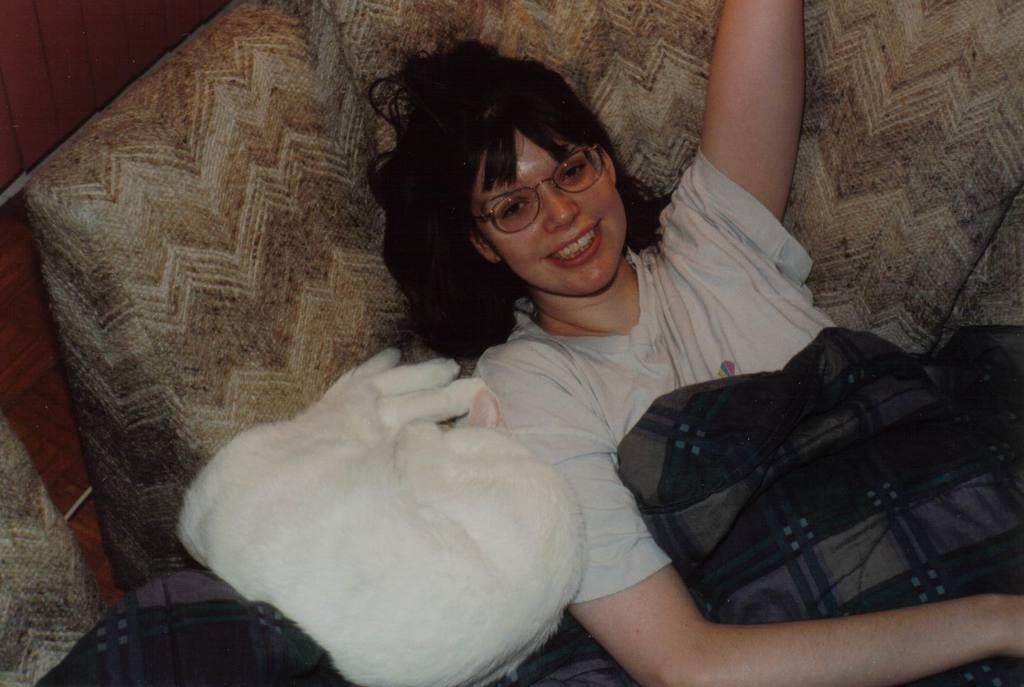Who is present in the image? There is a woman in the image. What is the woman doing in the image? The woman is lying on a couch or a bed. Are there any animals present in the image? Yes, there is a cat in the image. Is the drain visible in the image? No, there is no drain present in the image. 